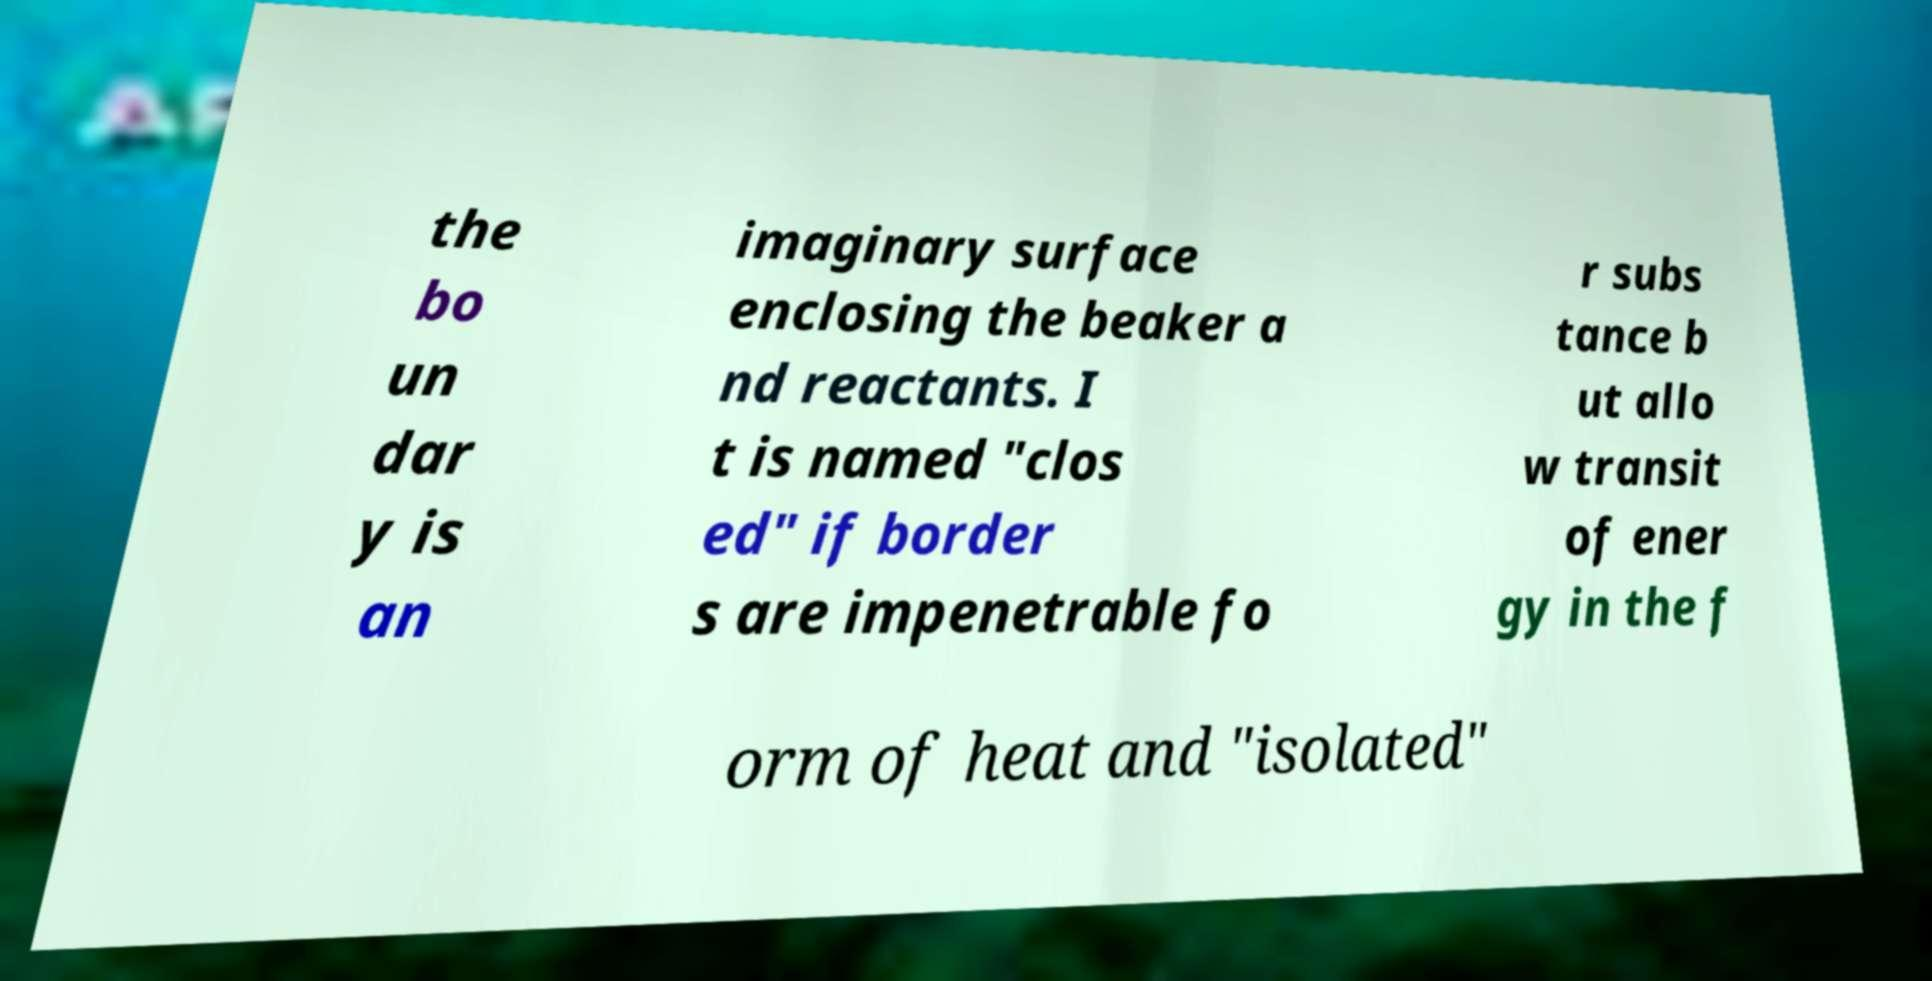Please read and relay the text visible in this image. What does it say? the bo un dar y is an imaginary surface enclosing the beaker a nd reactants. I t is named "clos ed" if border s are impenetrable fo r subs tance b ut allo w transit of ener gy in the f orm of heat and "isolated" 